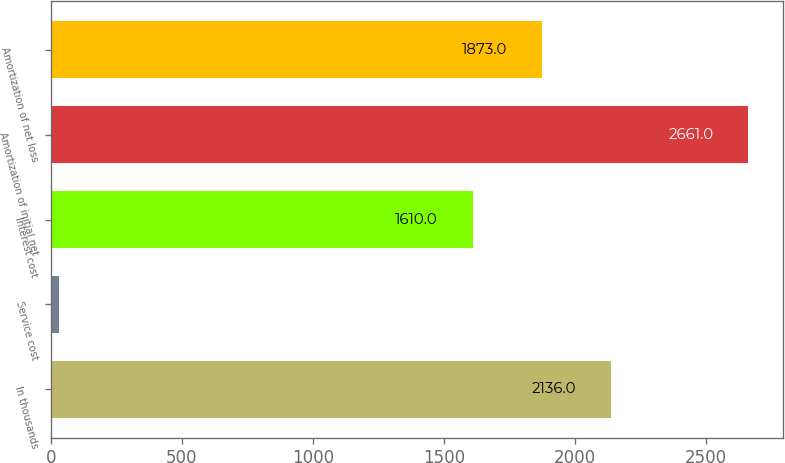Convert chart to OTSL. <chart><loc_0><loc_0><loc_500><loc_500><bar_chart><fcel>In thousands<fcel>Service cost<fcel>Interest cost<fcel>Amortization of initial net<fcel>Amortization of net loss<nl><fcel>2136<fcel>31<fcel>1610<fcel>2661<fcel>1873<nl></chart> 